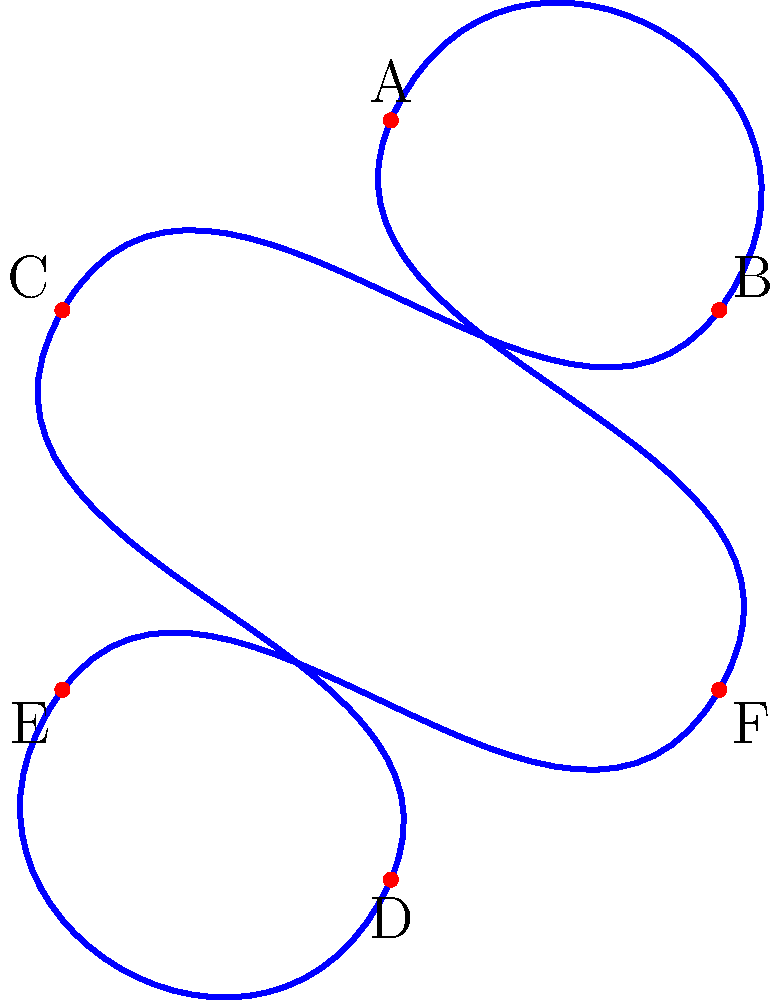Consider the trefoil knot shown above. Which of the following is a knot invariant that can distinguish this trefoil knot from its mirror image?

a) Crossing number
b) Unknotting number
c) Tricolorability
d) Jones polynomial To answer this question, let's consider each option:

1. Crossing number: The crossing number is the minimum number of crossings in any diagram of the knot. For the trefoil knot, it's 3. However, this is the same for both the left-handed and right-handed trefoil knots, so it can't distinguish between them.

2. Unknotting number: This is the minimum number of times the knot must be passed through itself to untie it. For the trefoil knot, it's 1. Again, this is the same for both orientations of the trefoil knot.

3. Tricolorability: A knot is tricolorable if its strands can be colored using three colors such that at each crossing, either all three colors are present or only one color is present. The trefoil knot is tricolorable, but this property is shared by both its left-handed and right-handed versions.

4. Jones polynomial: The Jones polynomial is a sophisticated knot invariant that can distinguish between a knot and its mirror image in many cases, including for the trefoil knot. The Jones polynomial for a left-handed trefoil is different from that of a right-handed trefoil.

For a left-handed trefoil: $V(t) = t + t^3 - t^4$
For a right-handed trefoil: $V(t) = t^{-1} + t^{-3} - t^{-4}$

These polynomials are different, showing that the Jones polynomial can distinguish between the trefoil and its mirror image.

Therefore, among the given options, only the Jones polynomial can distinguish the trefoil knot from its mirror image.
Answer: d) Jones polynomial 